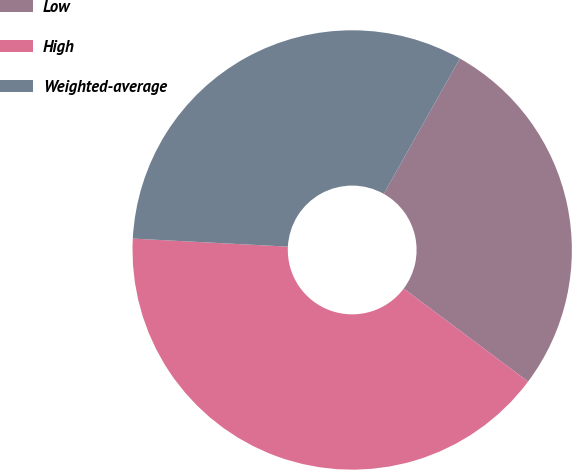Convert chart to OTSL. <chart><loc_0><loc_0><loc_500><loc_500><pie_chart><fcel>Low<fcel>High<fcel>Weighted-average<nl><fcel>27.07%<fcel>40.6%<fcel>32.33%<nl></chart> 